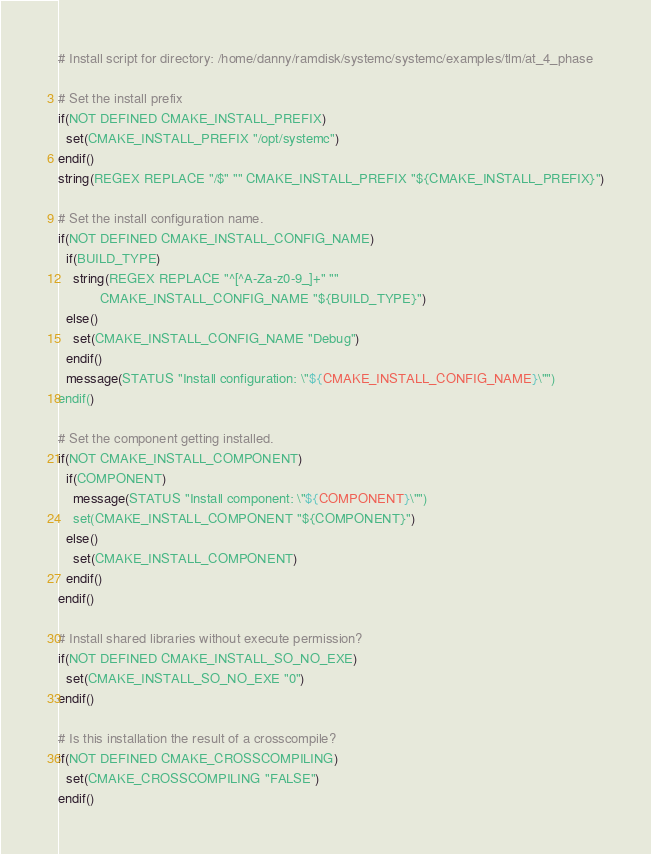Convert code to text. <code><loc_0><loc_0><loc_500><loc_500><_CMake_># Install script for directory: /home/danny/ramdisk/systemc/systemc/examples/tlm/at_4_phase

# Set the install prefix
if(NOT DEFINED CMAKE_INSTALL_PREFIX)
  set(CMAKE_INSTALL_PREFIX "/opt/systemc")
endif()
string(REGEX REPLACE "/$" "" CMAKE_INSTALL_PREFIX "${CMAKE_INSTALL_PREFIX}")

# Set the install configuration name.
if(NOT DEFINED CMAKE_INSTALL_CONFIG_NAME)
  if(BUILD_TYPE)
    string(REGEX REPLACE "^[^A-Za-z0-9_]+" ""
           CMAKE_INSTALL_CONFIG_NAME "${BUILD_TYPE}")
  else()
    set(CMAKE_INSTALL_CONFIG_NAME "Debug")
  endif()
  message(STATUS "Install configuration: \"${CMAKE_INSTALL_CONFIG_NAME}\"")
endif()

# Set the component getting installed.
if(NOT CMAKE_INSTALL_COMPONENT)
  if(COMPONENT)
    message(STATUS "Install component: \"${COMPONENT}\"")
    set(CMAKE_INSTALL_COMPONENT "${COMPONENT}")
  else()
    set(CMAKE_INSTALL_COMPONENT)
  endif()
endif()

# Install shared libraries without execute permission?
if(NOT DEFINED CMAKE_INSTALL_SO_NO_EXE)
  set(CMAKE_INSTALL_SO_NO_EXE "0")
endif()

# Is this installation the result of a crosscompile?
if(NOT DEFINED CMAKE_CROSSCOMPILING)
  set(CMAKE_CROSSCOMPILING "FALSE")
endif()

</code> 